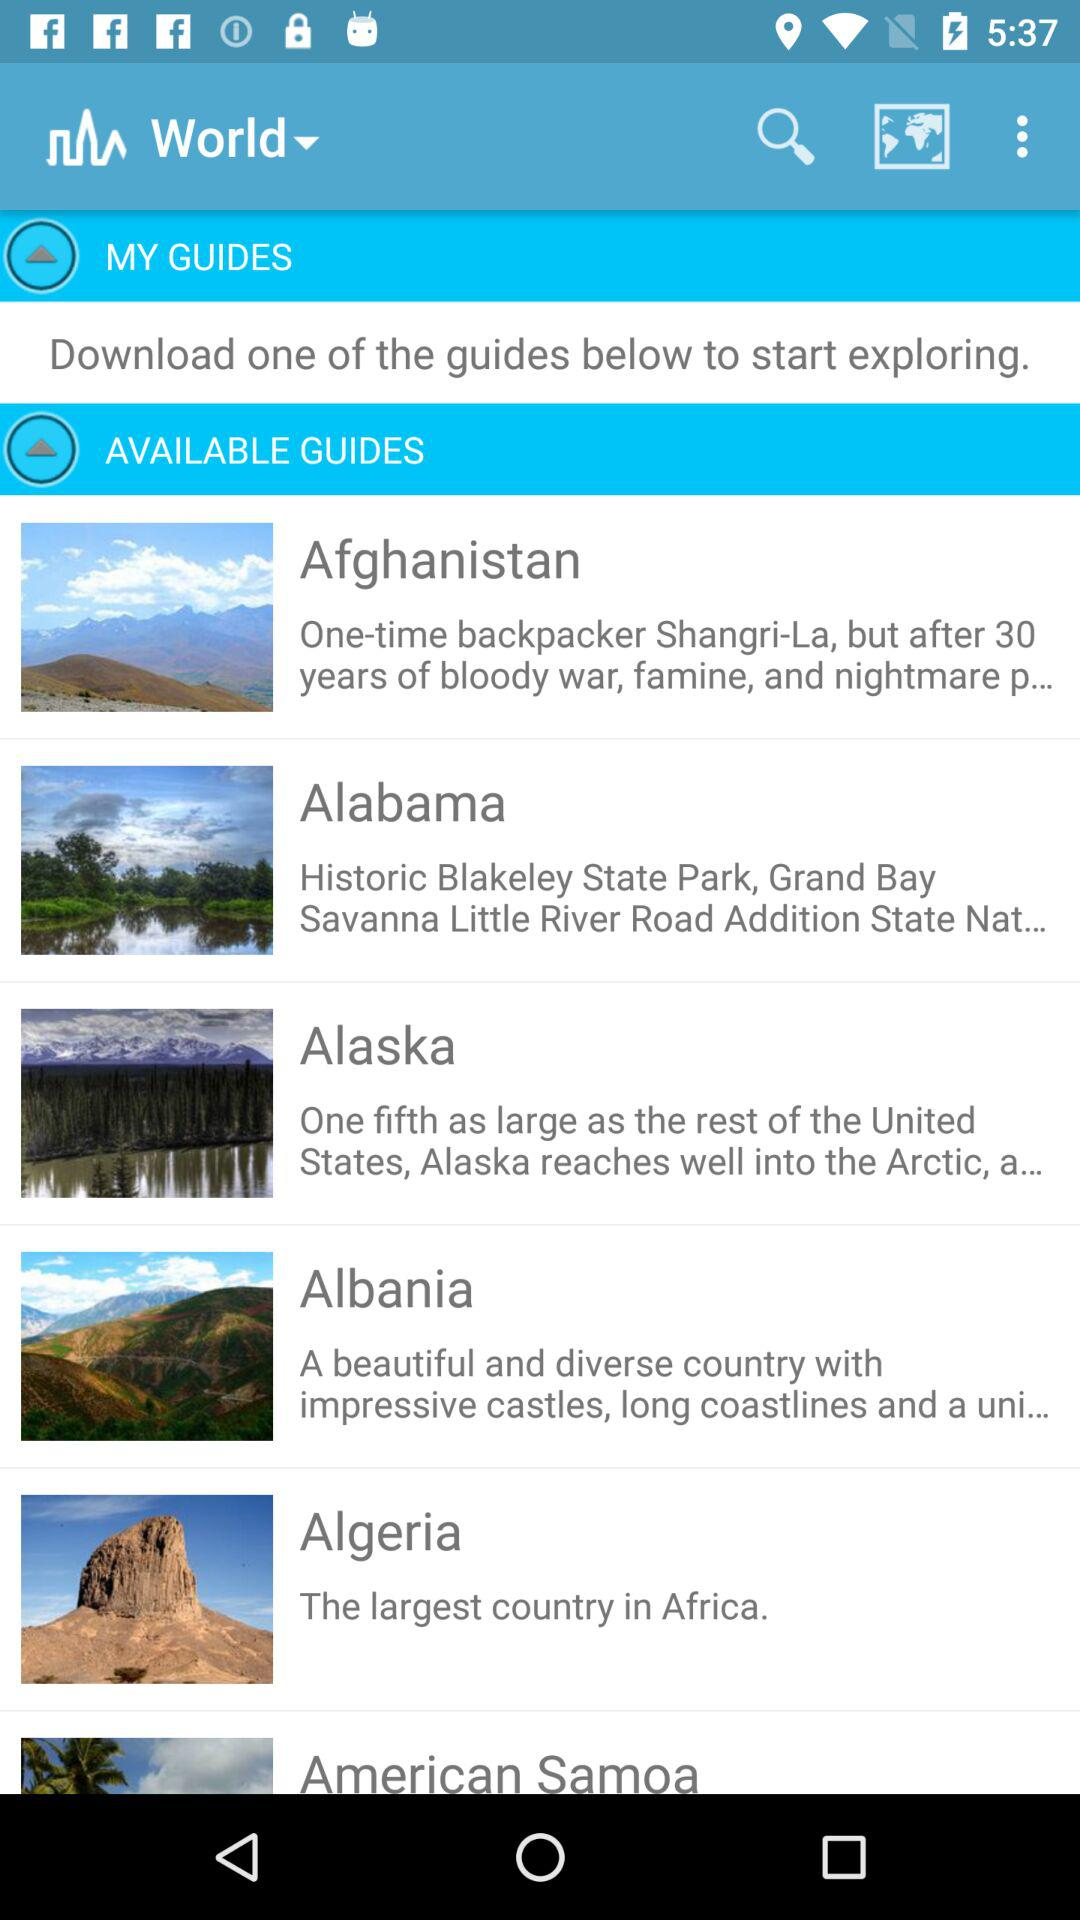How many guides are available?
Answer the question using a single word or phrase. 6 